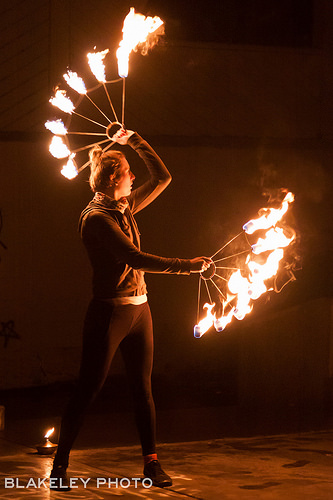<image>
Is there a fire on the girl? No. The fire is not positioned on the girl. They may be near each other, but the fire is not supported by or resting on top of the girl. Where is the fire in relation to the man? Is it behind the man? Yes. From this viewpoint, the fire is positioned behind the man, with the man partially or fully occluding the fire. 